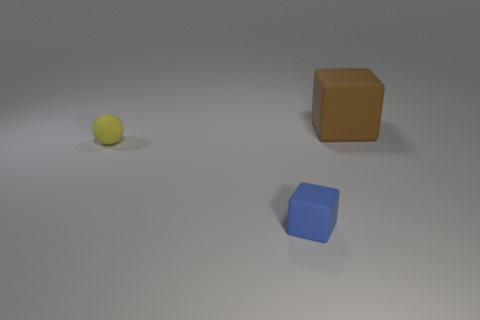How many brown rubber blocks are to the right of the block that is in front of the small thing behind the tiny blue rubber thing?
Provide a short and direct response. 1. There is a tiny blue object that is the same shape as the big matte object; what is it made of?
Ensure brevity in your answer.  Rubber. Is there any other thing that has the same material as the big brown thing?
Give a very brief answer. Yes. There is a block behind the tiny rubber ball; what color is it?
Your response must be concise. Brown. Is the material of the large brown thing the same as the block in front of the brown rubber thing?
Your response must be concise. Yes. What material is the brown block?
Offer a very short reply. Rubber. What shape is the tiny blue object that is made of the same material as the large cube?
Provide a short and direct response. Cube. What number of other things are the same shape as the tiny blue thing?
Make the answer very short. 1. How many small rubber objects are on the left side of the tiny blue cube?
Your answer should be very brief. 1. There is a block behind the tiny sphere; is it the same size as the thing that is on the left side of the blue block?
Your answer should be compact. No. 